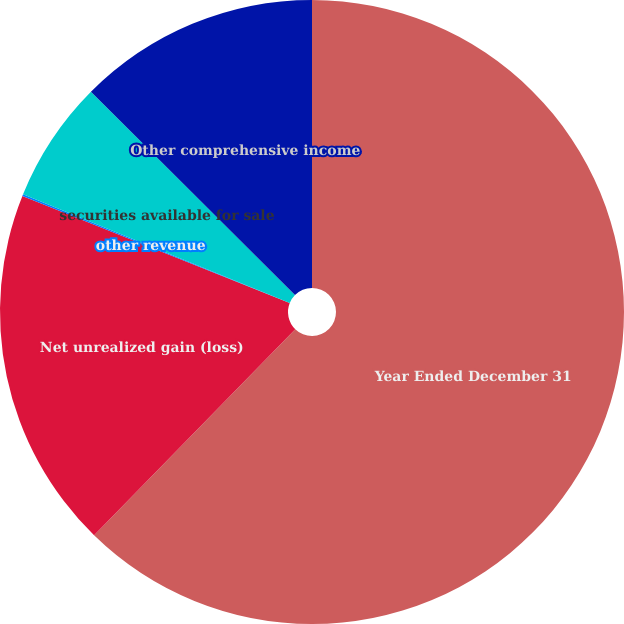Convert chart to OTSL. <chart><loc_0><loc_0><loc_500><loc_500><pie_chart><fcel>Year Ended December 31<fcel>Net unrealized gain (loss)<fcel>other revenue<fcel>securities available for sale<fcel>Other comprehensive income<nl><fcel>62.3%<fcel>18.76%<fcel>0.09%<fcel>6.31%<fcel>12.53%<nl></chart> 